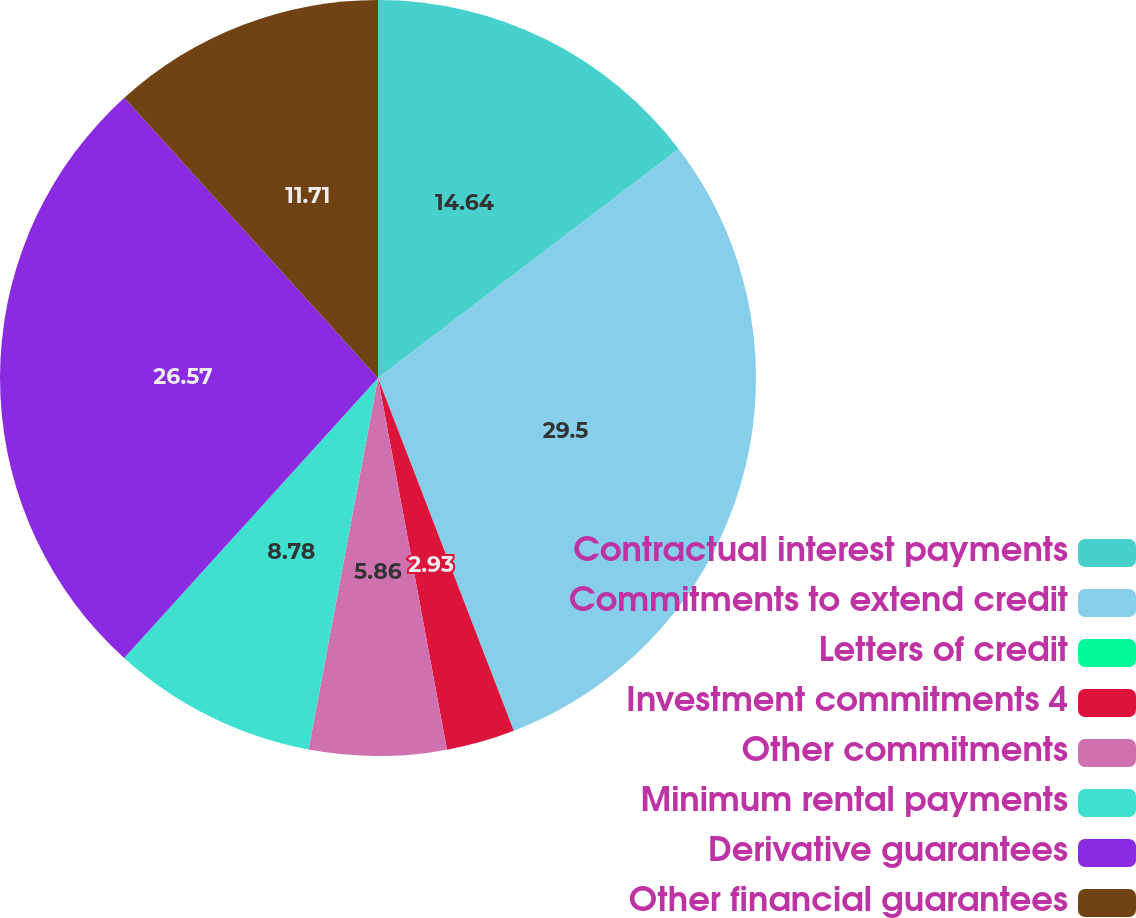Convert chart. <chart><loc_0><loc_0><loc_500><loc_500><pie_chart><fcel>Contractual interest payments<fcel>Commitments to extend credit<fcel>Letters of credit<fcel>Investment commitments 4<fcel>Other commitments<fcel>Minimum rental payments<fcel>Derivative guarantees<fcel>Other financial guarantees<nl><fcel>14.64%<fcel>29.5%<fcel>0.01%<fcel>2.93%<fcel>5.86%<fcel>8.78%<fcel>26.57%<fcel>11.71%<nl></chart> 